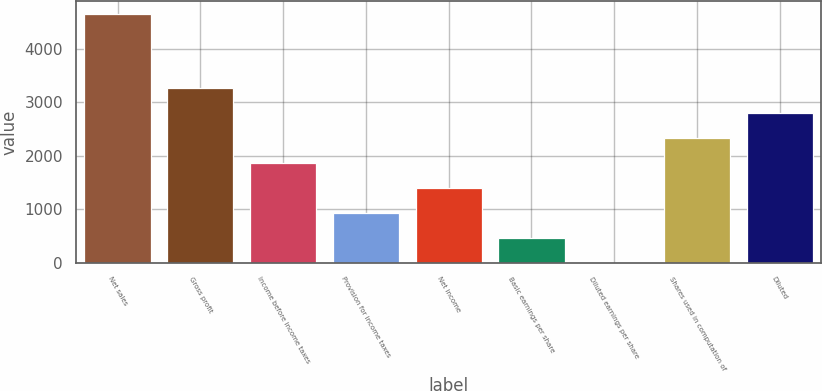Convert chart. <chart><loc_0><loc_0><loc_500><loc_500><bar_chart><fcel>Net sales<fcel>Gross profit<fcel>Income before income taxes<fcel>Provision for income taxes<fcel>Net income<fcel>Basic earnings per share<fcel>Diluted earnings per share<fcel>Shares used in computation of<fcel>Diluted<nl><fcel>4651<fcel>3255.81<fcel>1860.6<fcel>930.46<fcel>1395.53<fcel>465.39<fcel>0.32<fcel>2325.67<fcel>2790.74<nl></chart> 